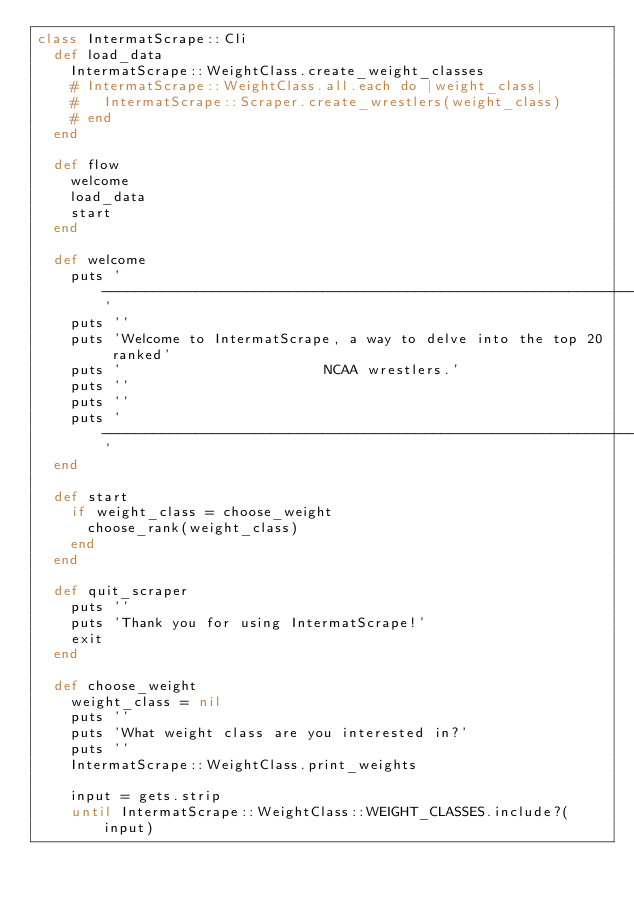<code> <loc_0><loc_0><loc_500><loc_500><_Ruby_>class IntermatScrape::Cli
  def load_data
    IntermatScrape::WeightClass.create_weight_classes
    # IntermatScrape::WeightClass.all.each do |weight_class|
    #   IntermatScrape::Scraper.create_wrestlers(weight_class)
    # end
  end

  def flow
    welcome
    load_data
    start
  end

  def welcome
    puts '-----------------------------------------------------------------'
    puts ''
    puts 'Welcome to IntermatScrape, a way to delve into the top 20 ranked'
    puts '                        NCAA wrestlers.'
    puts ''
    puts ''
    puts '-----------------------------------------------------------------'
  end

  def start
    if weight_class = choose_weight
      choose_rank(weight_class)
    end
  end

  def quit_scraper
    puts ''
    puts 'Thank you for using IntermatScrape!'
    exit
  end

  def choose_weight
    weight_class = nil
    puts ''
    puts 'What weight class are you interested in?'
    puts ''
    IntermatScrape::WeightClass.print_weights

    input = gets.strip
    until IntermatScrape::WeightClass::WEIGHT_CLASSES.include?(input)</code> 